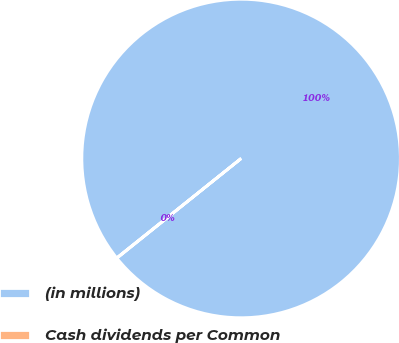Convert chart. <chart><loc_0><loc_0><loc_500><loc_500><pie_chart><fcel>(in millions)<fcel>Cash dividends per Common<nl><fcel>99.97%<fcel>0.03%<nl></chart> 